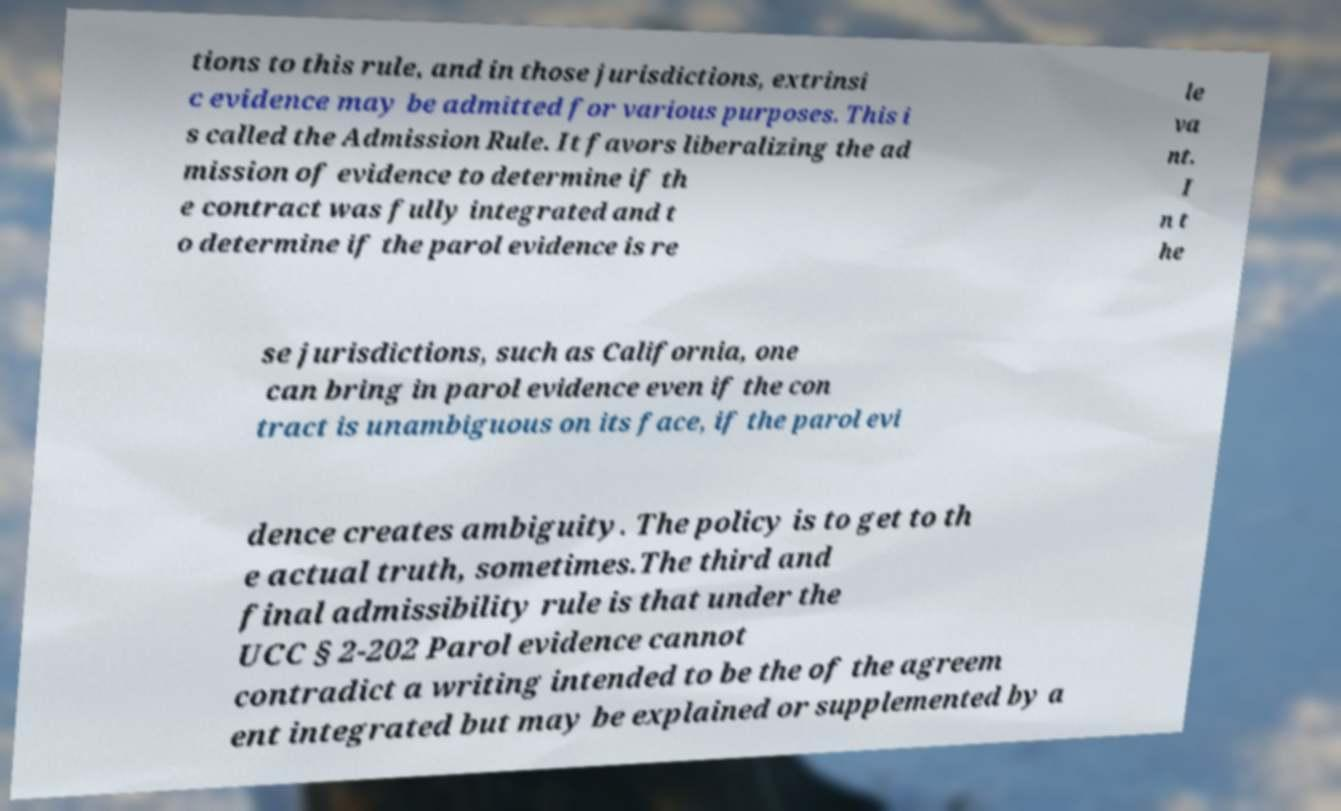Please read and relay the text visible in this image. What does it say? tions to this rule, and in those jurisdictions, extrinsi c evidence may be admitted for various purposes. This i s called the Admission Rule. It favors liberalizing the ad mission of evidence to determine if th e contract was fully integrated and t o determine if the parol evidence is re le va nt. I n t he se jurisdictions, such as California, one can bring in parol evidence even if the con tract is unambiguous on its face, if the parol evi dence creates ambiguity. The policy is to get to th e actual truth, sometimes.The third and final admissibility rule is that under the UCC § 2-202 Parol evidence cannot contradict a writing intended to be the of the agreem ent integrated but may be explained or supplemented by a 